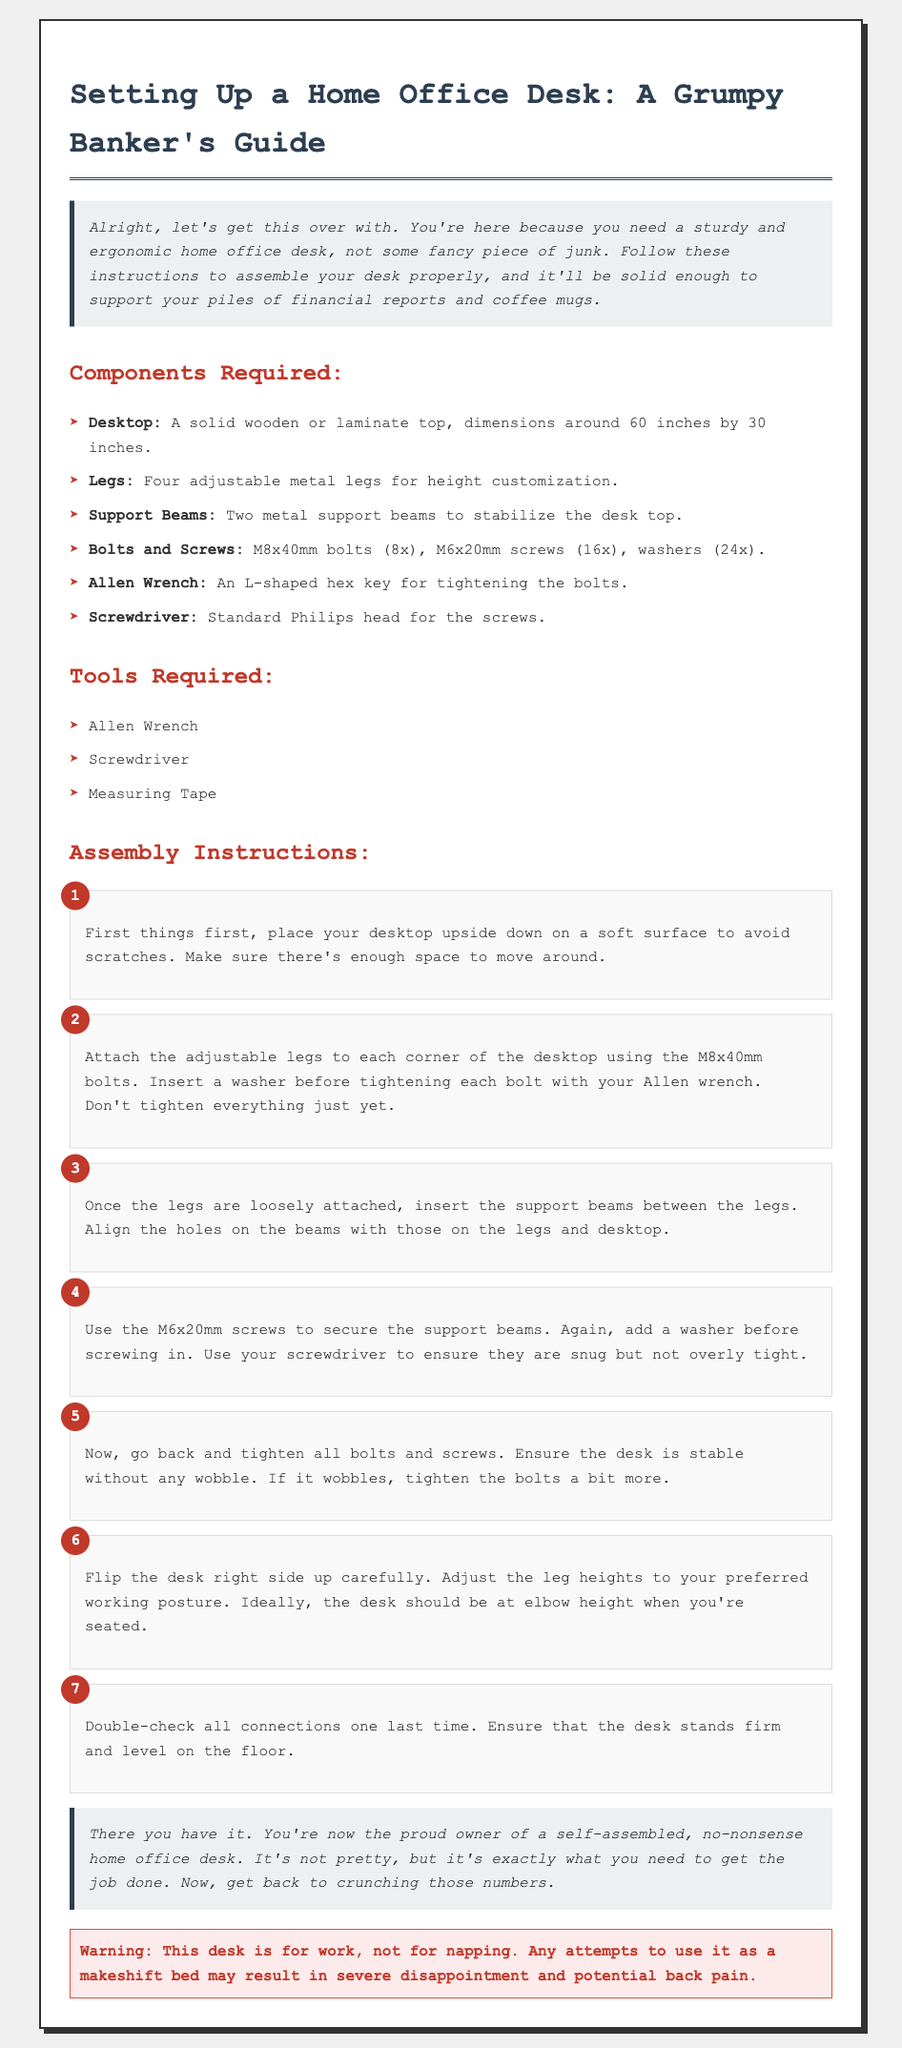What are the dimensions of the desktop? The dimensions of the desktop specified in the document are around 60 inches by 30 inches.
Answer: 60 inches by 30 inches How many adjustable legs are required? The document states that four adjustable metal legs are needed for assembly.
Answer: Four What type of screws are used for securing the support beams? It specifies the use of M6x20mm screws to secure the support beams.
Answer: M6x20mm screws What tool is needed to tighten the bolts? The document mentions that an Allen wrench is necessary for tightening the bolts.
Answer: Allen wrench In which step do you assemble the support beams? The support beams are inserted between the legs in step 3 of the assembly instructions.
Answer: Step 3 How many washers are required in total? The document states that 24 washers are needed when assembling the desk.
Answer: 24 washers What should the desk height ideally be? The document recommends that the desk should be at elbow height when seated.
Answer: Elbow height What is the final step in the assembly process? The last step involves double-checking all connections to ensure the desk is stable and level.
Answer: Double-check connections What purpose does the warning serve in the document? The warning cautions against using the desk as a makeshift bed, emphasizing its intended use for work.
Answer: Intended use for work 